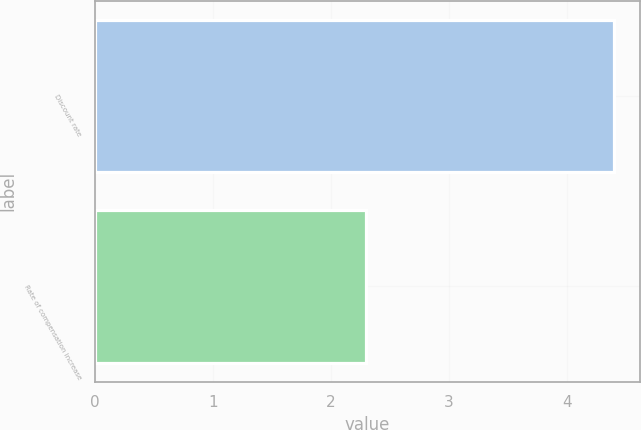<chart> <loc_0><loc_0><loc_500><loc_500><bar_chart><fcel>Discount rate<fcel>Rate of compensation increase<nl><fcel>4.4<fcel>2.3<nl></chart> 